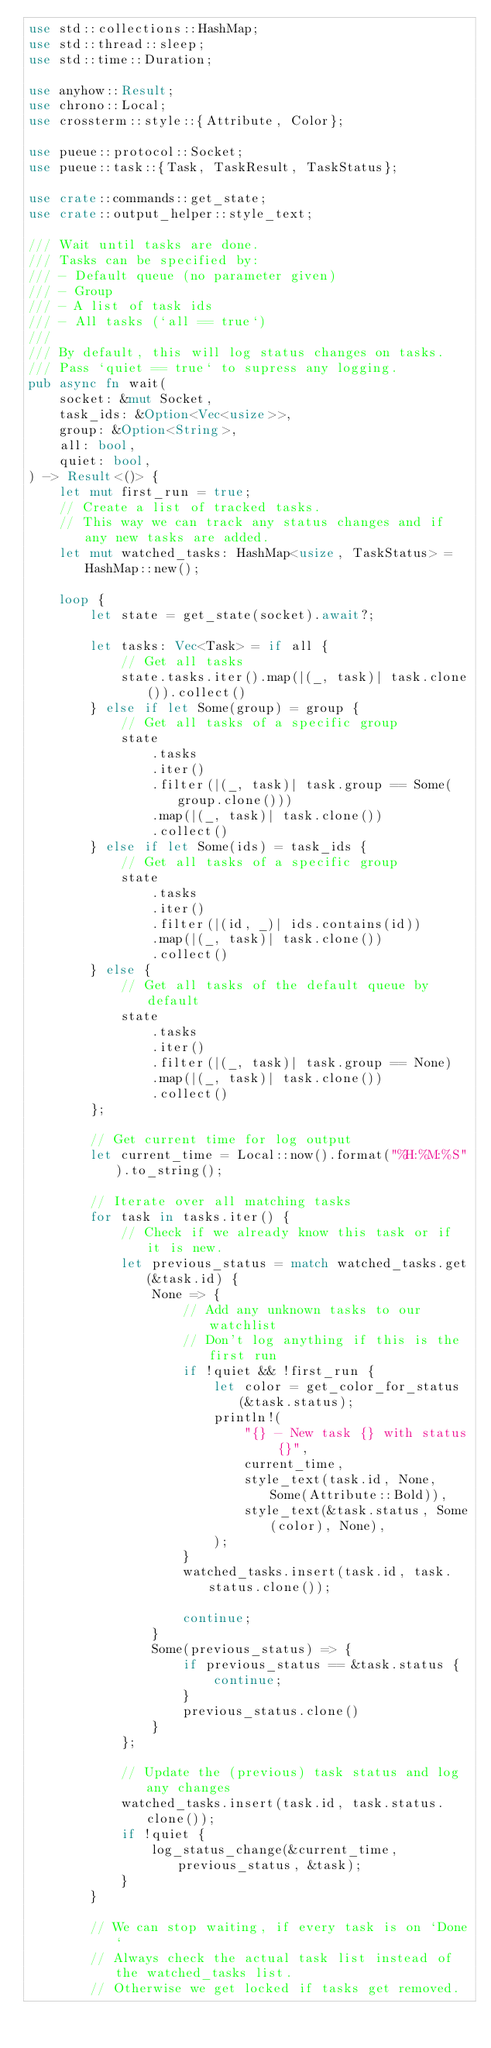Convert code to text. <code><loc_0><loc_0><loc_500><loc_500><_Rust_>use std::collections::HashMap;
use std::thread::sleep;
use std::time::Duration;

use anyhow::Result;
use chrono::Local;
use crossterm::style::{Attribute, Color};

use pueue::protocol::Socket;
use pueue::task::{Task, TaskResult, TaskStatus};

use crate::commands::get_state;
use crate::output_helper::style_text;

/// Wait until tasks are done.
/// Tasks can be specified by:
/// - Default queue (no parameter given)
/// - Group
/// - A list of task ids
/// - All tasks (`all == true`)
///
/// By default, this will log status changes on tasks.
/// Pass `quiet == true` to supress any logging.
pub async fn wait(
    socket: &mut Socket,
    task_ids: &Option<Vec<usize>>,
    group: &Option<String>,
    all: bool,
    quiet: bool,
) -> Result<()> {
    let mut first_run = true;
    // Create a list of tracked tasks.
    // This way we can track any status changes and if any new tasks are added.
    let mut watched_tasks: HashMap<usize, TaskStatus> = HashMap::new();

    loop {
        let state = get_state(socket).await?;

        let tasks: Vec<Task> = if all {
            // Get all tasks
            state.tasks.iter().map(|(_, task)| task.clone()).collect()
        } else if let Some(group) = group {
            // Get all tasks of a specific group
            state
                .tasks
                .iter()
                .filter(|(_, task)| task.group == Some(group.clone()))
                .map(|(_, task)| task.clone())
                .collect()
        } else if let Some(ids) = task_ids {
            // Get all tasks of a specific group
            state
                .tasks
                .iter()
                .filter(|(id, _)| ids.contains(id))
                .map(|(_, task)| task.clone())
                .collect()
        } else {
            // Get all tasks of the default queue by default
            state
                .tasks
                .iter()
                .filter(|(_, task)| task.group == None)
                .map(|(_, task)| task.clone())
                .collect()
        };

        // Get current time for log output
        let current_time = Local::now().format("%H:%M:%S").to_string();

        // Iterate over all matching tasks
        for task in tasks.iter() {
            // Check if we already know this task or if it is new.
            let previous_status = match watched_tasks.get(&task.id) {
                None => {
                    // Add any unknown tasks to our watchlist
                    // Don't log anything if this is the first run
                    if !quiet && !first_run {
                        let color = get_color_for_status(&task.status);
                        println!(
                            "{} - New task {} with status {}",
                            current_time,
                            style_text(task.id, None, Some(Attribute::Bold)),
                            style_text(&task.status, Some(color), None),
                        );
                    }
                    watched_tasks.insert(task.id, task.status.clone());

                    continue;
                }
                Some(previous_status) => {
                    if previous_status == &task.status {
                        continue;
                    }
                    previous_status.clone()
                }
            };

            // Update the (previous) task status and log any changes
            watched_tasks.insert(task.id, task.status.clone());
            if !quiet {
                log_status_change(&current_time, previous_status, &task);
            }
        }

        // We can stop waiting, if every task is on `Done`
        // Always check the actual task list instead of the watched_tasks list.
        // Otherwise we get locked if tasks get removed.</code> 